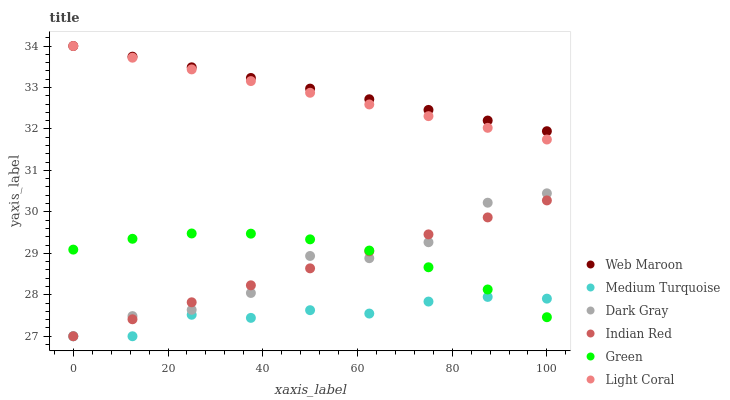Does Medium Turquoise have the minimum area under the curve?
Answer yes or no. Yes. Does Web Maroon have the maximum area under the curve?
Answer yes or no. Yes. Does Web Maroon have the minimum area under the curve?
Answer yes or no. No. Does Medium Turquoise have the maximum area under the curve?
Answer yes or no. No. Is Indian Red the smoothest?
Answer yes or no. Yes. Is Dark Gray the roughest?
Answer yes or no. Yes. Is Medium Turquoise the smoothest?
Answer yes or no. No. Is Medium Turquoise the roughest?
Answer yes or no. No. Does Medium Turquoise have the lowest value?
Answer yes or no. Yes. Does Web Maroon have the lowest value?
Answer yes or no. No. Does Web Maroon have the highest value?
Answer yes or no. Yes. Does Medium Turquoise have the highest value?
Answer yes or no. No. Is Indian Red less than Light Coral?
Answer yes or no. Yes. Is Web Maroon greater than Green?
Answer yes or no. Yes. Does Dark Gray intersect Medium Turquoise?
Answer yes or no. Yes. Is Dark Gray less than Medium Turquoise?
Answer yes or no. No. Is Dark Gray greater than Medium Turquoise?
Answer yes or no. No. Does Indian Red intersect Light Coral?
Answer yes or no. No. 